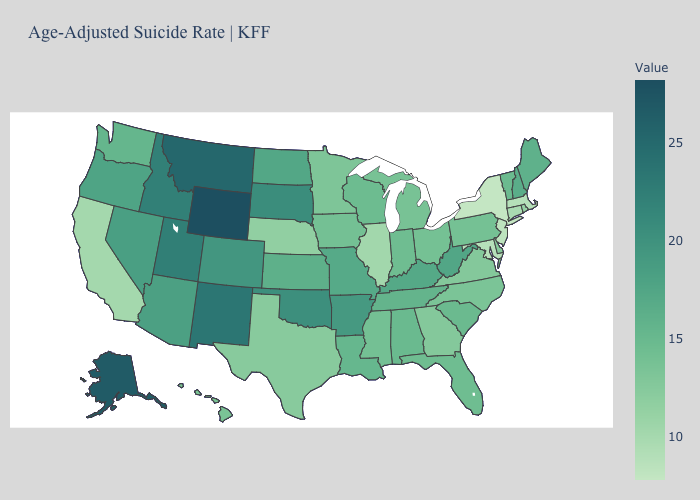Does the map have missing data?
Concise answer only. No. Does the map have missing data?
Write a very short answer. No. Among the states that border Delaware , which have the lowest value?
Give a very brief answer. New Jersey. Among the states that border Rhode Island , does Massachusetts have the lowest value?
Short answer required. Yes. Which states have the highest value in the USA?
Give a very brief answer. Wyoming. 